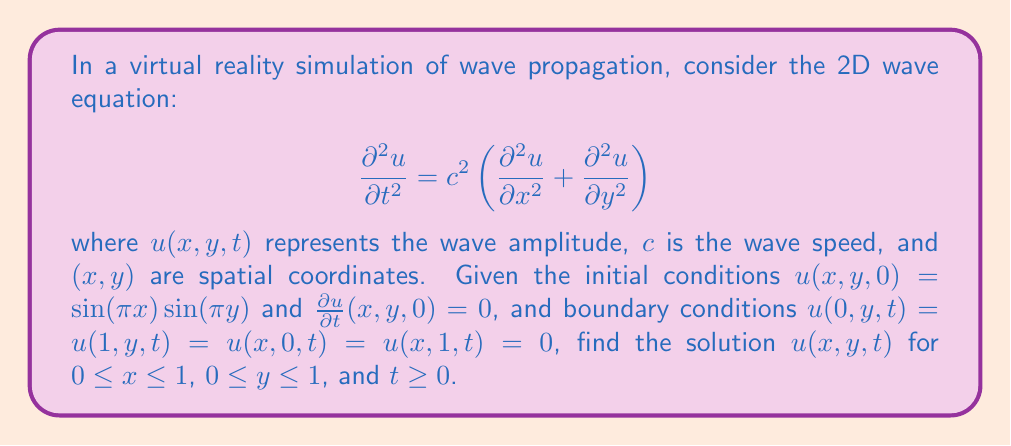Show me your answer to this math problem. To solve this partial differential equation (PDE), we'll use the method of separation of variables:

1) Assume the solution has the form: $u(x,y,t) = X(x)Y(y)T(t)$

2) Substitute this into the PDE:
   $$X(x)Y(y)T''(t) = c^2[X''(x)Y(y)T(t) + X(x)Y''(y)T(t)]$$

3) Divide by $X(x)Y(y)T(t)$:
   $$\frac{T''(t)}{T(t)} = c^2\left[\frac{X''(x)}{X(x)} + \frac{Y''(y)}{Y(y)}\right]$$

4) The left side depends only on $t$, and the right side only on $x$ and $y$. This is possible only if both sides are equal to a constant, say $-\omega^2$:
   $$\frac{T''(t)}{T(t)} = -\omega^2$$
   $$c^2\left[\frac{X''(x)}{X(x)} + \frac{Y''(y)}{Y(y)}\right] = -\omega^2$$

5) From the $t$ equation: $T(t) = A\cos(\omega t) + B\sin(\omega t)$

6) The $x$ and $y$ equations can be separated:
   $$\frac{X''(x)}{X(x)} = -k_x^2, \quad \frac{Y''(y)}{Y(y)} = -k_y^2$$
   where $k_x^2 + k_y^2 = \frac{\omega^2}{c^2}$

7) Solutions: $X(x) = \sin(k_x x)$, $Y(y) = \sin(k_y y)$

8) Apply boundary conditions:
   $X(0) = X(1) = 0 \implies k_x = n\pi$
   $Y(0) = Y(1) = 0 \implies k_y = m\pi$
   where $n, m$ are positive integers.

9) The general solution is:
   $$u(x,y,t) = \sum_{n=1}^{\infty}\sum_{m=1}^{\infty}[A_{nm}\cos(\omega_{nm}t) + B_{nm}\sin(\omega_{nm}t)]\sin(n\pi x)\sin(m\pi y)$$
   where $\omega_{nm} = c\pi\sqrt{n^2 + m^2}$

10) Apply initial conditions:
    $u(x,y,0) = \sin(\pi x)\sin(\pi y) \implies A_{11} = 1$, all other $A_{nm} = 0$
    $\frac{\partial u}{\partial t}(x,y,0) = 0 \implies$ all $B_{nm} = 0$

Therefore, the final solution is:
$$u(x,y,t) = \cos(c\pi\sqrt{2}t)\sin(\pi x)\sin(\pi y)$$
Answer: $u(x,y,t) = \cos(c\pi\sqrt{2}t)\sin(\pi x)\sin(\pi y)$ 